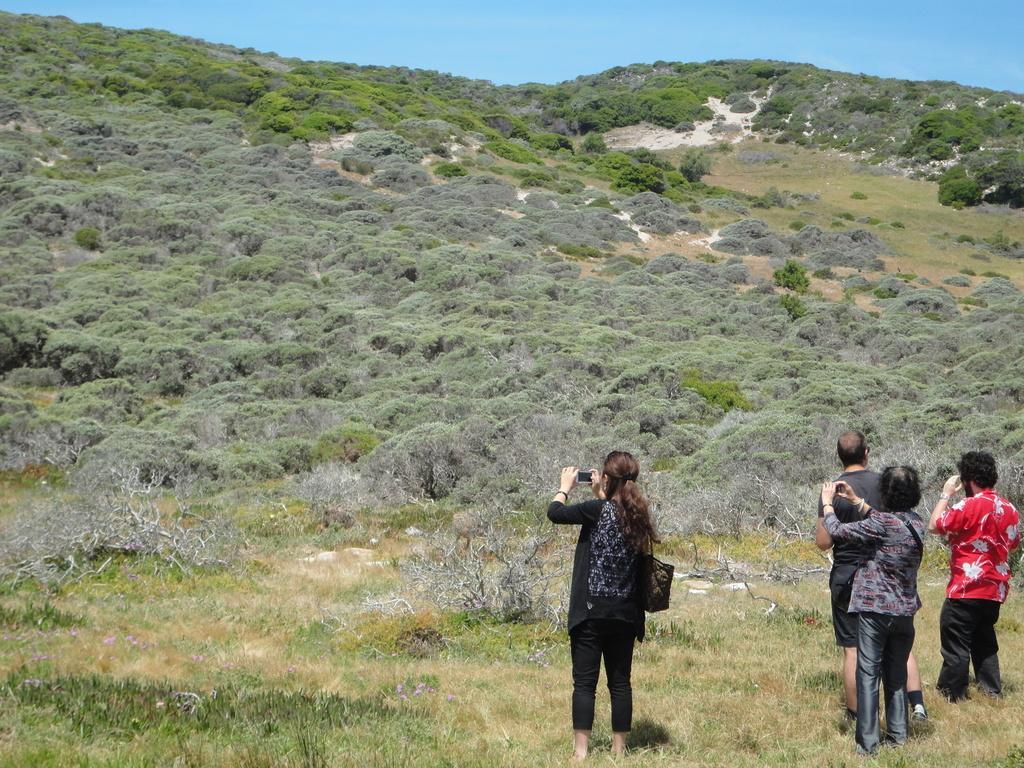Could you give a brief overview of what you see in this image? In this picture I can see there are some people standing here and holding mobile phones and in the backdrop there is a mountain and the mountain is covered with trees and the sky is clear. 